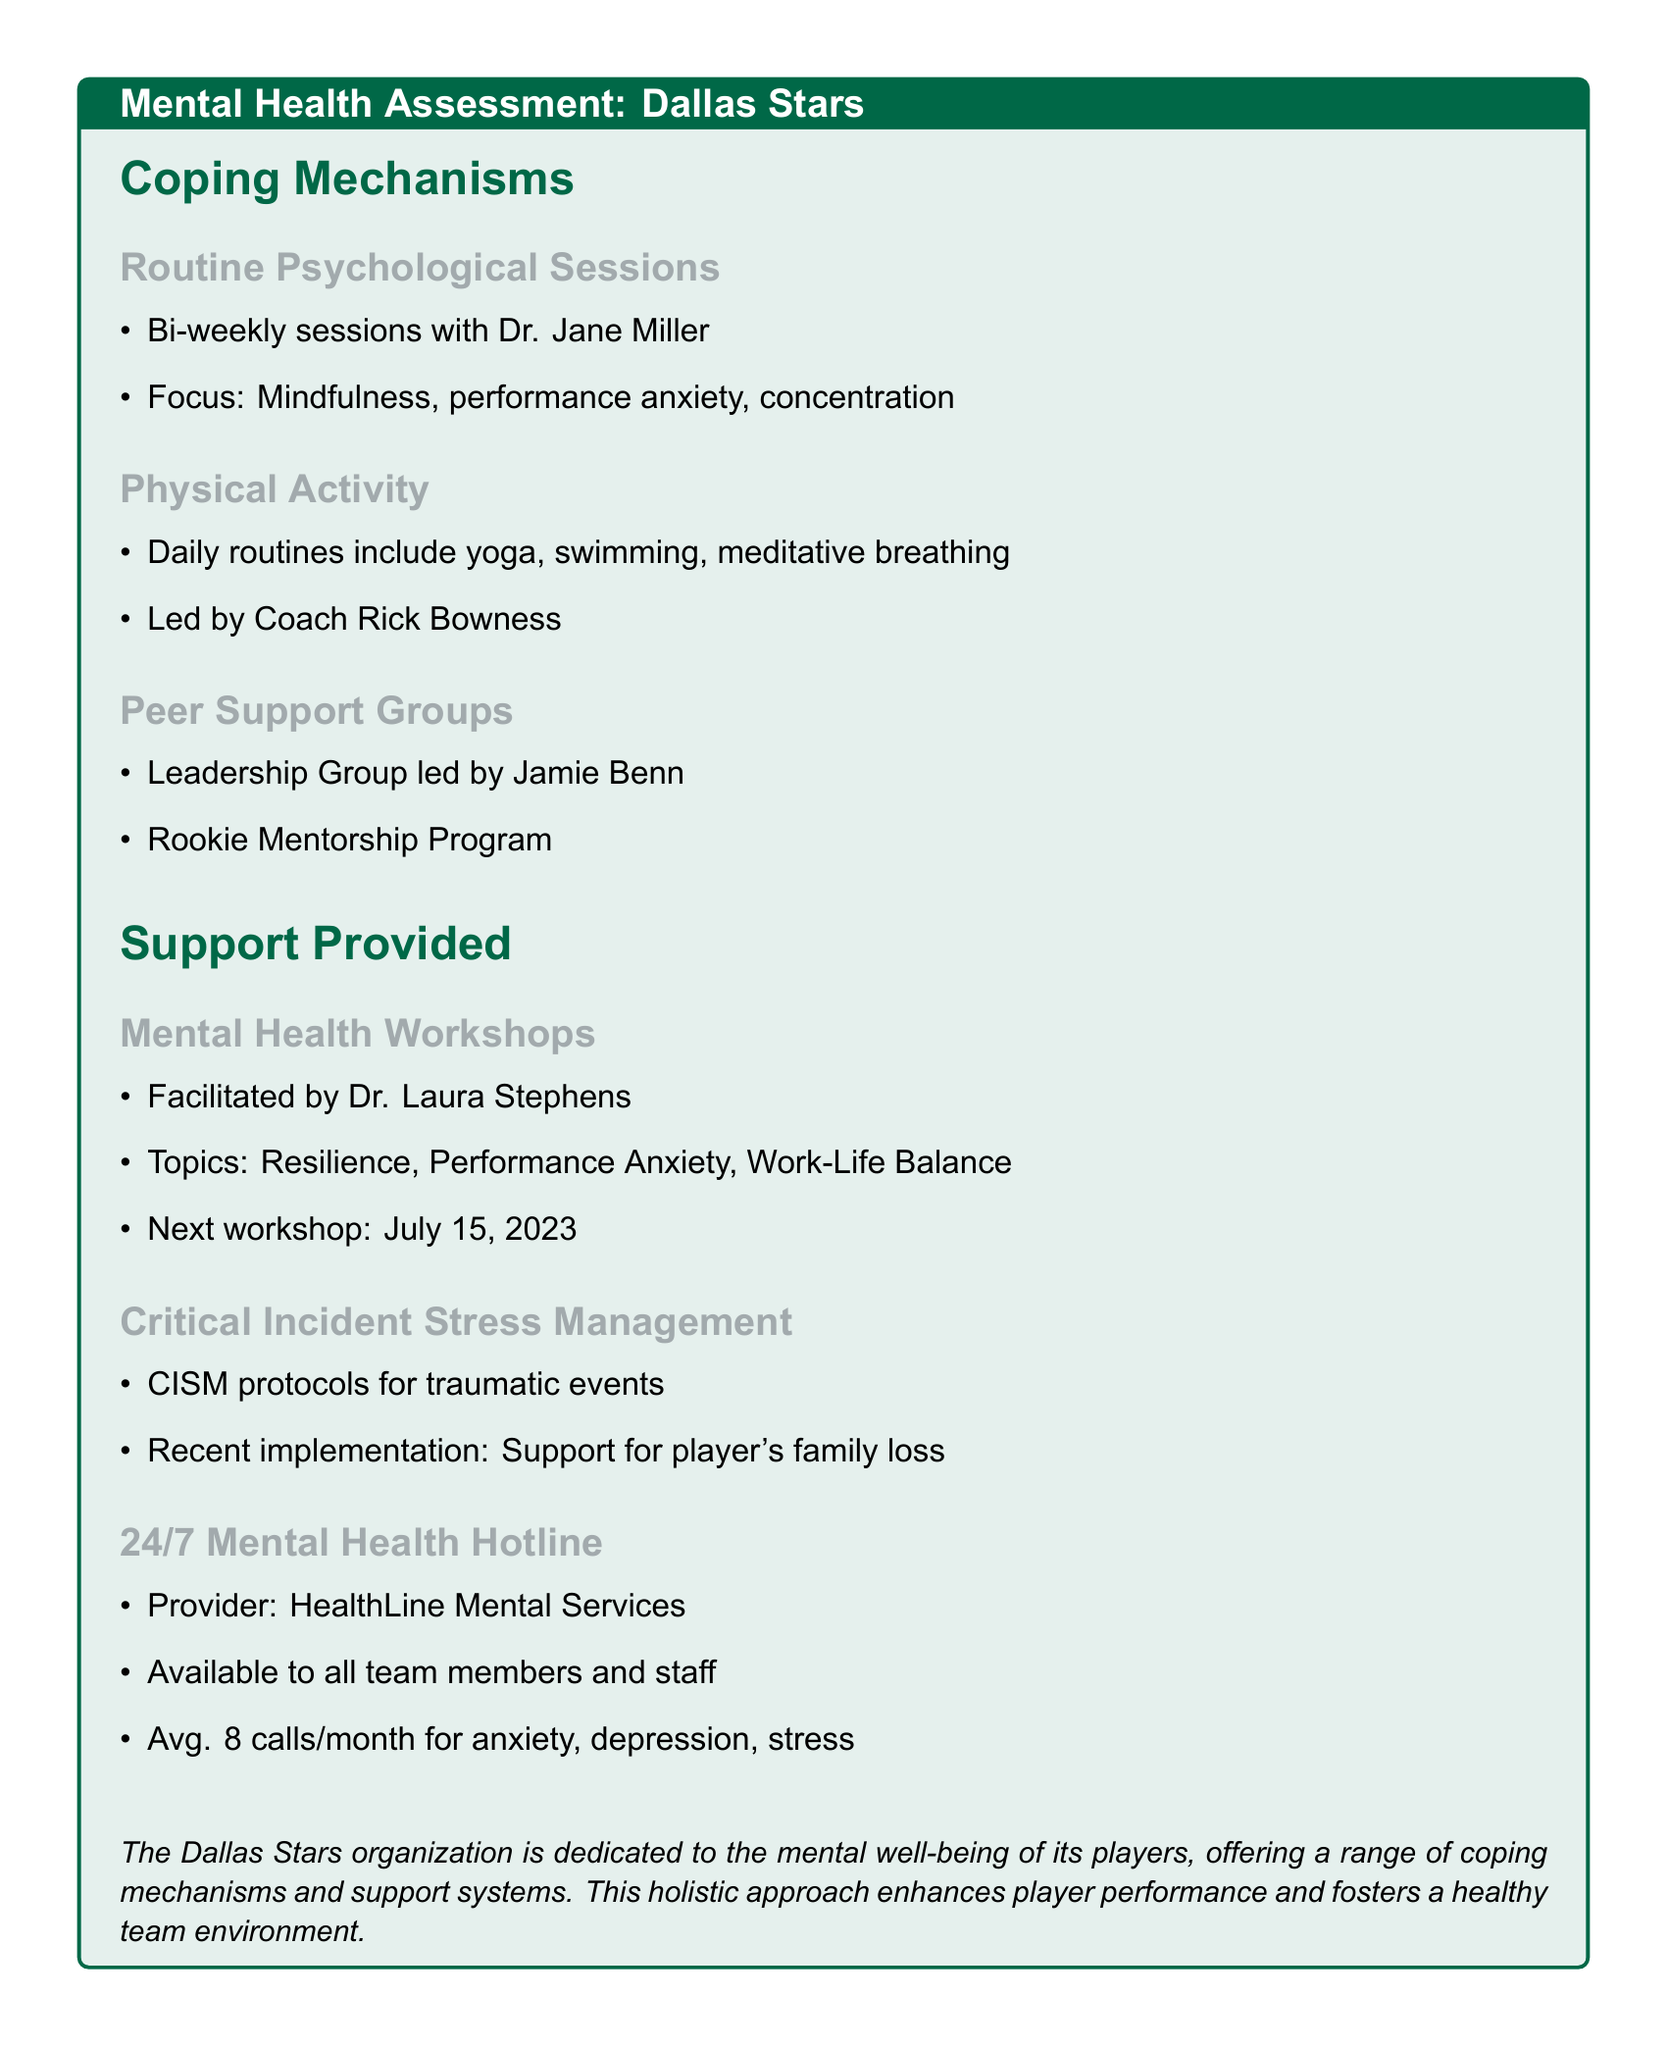What is the focus of the bi-weekly psychological sessions? The sessions focus on mindfulness, performance anxiety, and concentration as stated in the document.
Answer: Mindfulness, performance anxiety, concentration Who leads the peer support groups? The Leadership Group is led by Jamie Benn, as mentioned in the document.
Answer: Jamie Benn When is the next mental health workshop scheduled? The next workshop date is specified in the document as July 15, 2023.
Answer: July 15, 2023 What type of management protocols are in place for traumatic events? The document refers to Critical Incident Stress Management protocols for addressing traumatic experiences.
Answer: CISM protocols How many calls per month does the 24/7 mental health hotline receive on average? The average monthly calls for anxiety, depression, and stress is provided in the document as 8 calls.
Answer: 8 calls Which physical activities are included in the daily routines? The document lists yoga, swimming, and meditative breathing as part of the daily routines.
Answer: Yoga, swimming, meditative breathing What is the provider of the 24/7 mental health hotline? The document states that the hotline is provided by HealthLine Mental Services.
Answer: HealthLine Mental Services What is one of the topics covered in the mental health workshops? The document mentions resilience as one of the topics addressed in the workshops.
Answer: Resilience 